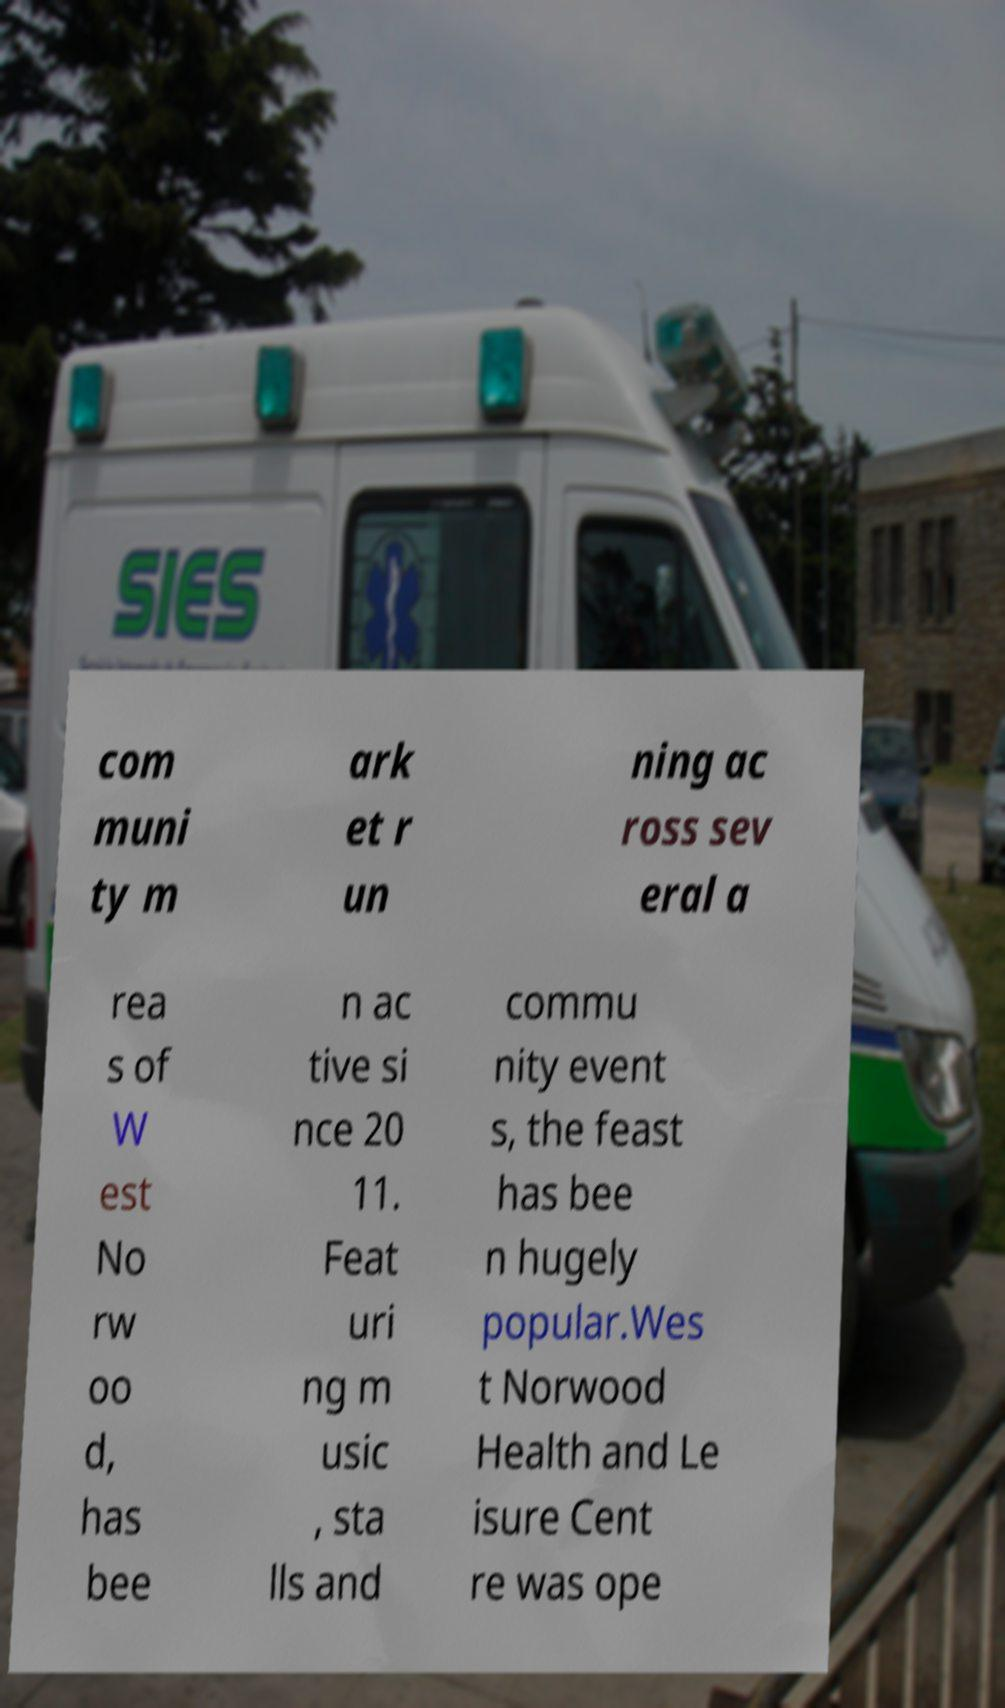I need the written content from this picture converted into text. Can you do that? com muni ty m ark et r un ning ac ross sev eral a rea s of W est No rw oo d, has bee n ac tive si nce 20 11. Feat uri ng m usic , sta lls and commu nity event s, the feast has bee n hugely popular.Wes t Norwood Health and Le isure Cent re was ope 